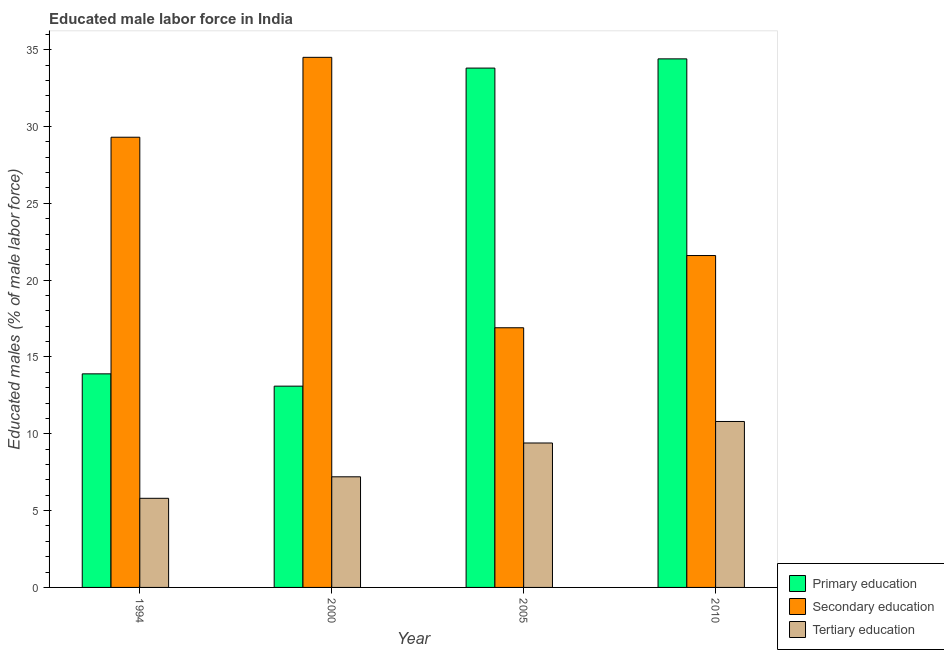How many different coloured bars are there?
Provide a short and direct response. 3. How many bars are there on the 1st tick from the left?
Provide a short and direct response. 3. How many bars are there on the 3rd tick from the right?
Give a very brief answer. 3. What is the label of the 4th group of bars from the left?
Your response must be concise. 2010. What is the percentage of male labor force who received primary education in 2010?
Your answer should be very brief. 34.4. Across all years, what is the maximum percentage of male labor force who received tertiary education?
Offer a very short reply. 10.8. Across all years, what is the minimum percentage of male labor force who received primary education?
Offer a terse response. 13.1. What is the total percentage of male labor force who received secondary education in the graph?
Your answer should be compact. 102.3. What is the difference between the percentage of male labor force who received tertiary education in 1994 and that in 2000?
Your response must be concise. -1.4. What is the difference between the percentage of male labor force who received primary education in 2000 and the percentage of male labor force who received tertiary education in 1994?
Your answer should be compact. -0.8. What is the average percentage of male labor force who received tertiary education per year?
Provide a succinct answer. 8.3. In the year 2005, what is the difference between the percentage of male labor force who received tertiary education and percentage of male labor force who received primary education?
Offer a terse response. 0. In how many years, is the percentage of male labor force who received tertiary education greater than 14 %?
Offer a terse response. 0. What is the ratio of the percentage of male labor force who received secondary education in 1994 to that in 2000?
Your answer should be compact. 0.85. Is the difference between the percentage of male labor force who received primary education in 2005 and 2010 greater than the difference between the percentage of male labor force who received tertiary education in 2005 and 2010?
Your answer should be compact. No. What is the difference between the highest and the second highest percentage of male labor force who received primary education?
Your answer should be very brief. 0.6. What is the difference between the highest and the lowest percentage of male labor force who received secondary education?
Offer a terse response. 17.6. In how many years, is the percentage of male labor force who received primary education greater than the average percentage of male labor force who received primary education taken over all years?
Your answer should be compact. 2. Is the sum of the percentage of male labor force who received tertiary education in 1994 and 2010 greater than the maximum percentage of male labor force who received primary education across all years?
Your answer should be very brief. Yes. What does the 2nd bar from the left in 2010 represents?
Make the answer very short. Secondary education. Is it the case that in every year, the sum of the percentage of male labor force who received primary education and percentage of male labor force who received secondary education is greater than the percentage of male labor force who received tertiary education?
Your response must be concise. Yes. How many bars are there?
Offer a terse response. 12. Are all the bars in the graph horizontal?
Give a very brief answer. No. How many years are there in the graph?
Your answer should be very brief. 4. Where does the legend appear in the graph?
Make the answer very short. Bottom right. How are the legend labels stacked?
Your answer should be compact. Vertical. What is the title of the graph?
Provide a succinct answer. Educated male labor force in India. Does "Ages 0-14" appear as one of the legend labels in the graph?
Your answer should be very brief. No. What is the label or title of the X-axis?
Your response must be concise. Year. What is the label or title of the Y-axis?
Keep it short and to the point. Educated males (% of male labor force). What is the Educated males (% of male labor force) in Primary education in 1994?
Your answer should be very brief. 13.9. What is the Educated males (% of male labor force) in Secondary education in 1994?
Your answer should be very brief. 29.3. What is the Educated males (% of male labor force) of Tertiary education in 1994?
Offer a very short reply. 5.8. What is the Educated males (% of male labor force) in Primary education in 2000?
Your answer should be compact. 13.1. What is the Educated males (% of male labor force) in Secondary education in 2000?
Make the answer very short. 34.5. What is the Educated males (% of male labor force) in Tertiary education in 2000?
Your answer should be very brief. 7.2. What is the Educated males (% of male labor force) in Primary education in 2005?
Keep it short and to the point. 33.8. What is the Educated males (% of male labor force) of Secondary education in 2005?
Your answer should be compact. 16.9. What is the Educated males (% of male labor force) in Tertiary education in 2005?
Offer a very short reply. 9.4. What is the Educated males (% of male labor force) in Primary education in 2010?
Ensure brevity in your answer.  34.4. What is the Educated males (% of male labor force) in Secondary education in 2010?
Keep it short and to the point. 21.6. What is the Educated males (% of male labor force) of Tertiary education in 2010?
Provide a short and direct response. 10.8. Across all years, what is the maximum Educated males (% of male labor force) in Primary education?
Give a very brief answer. 34.4. Across all years, what is the maximum Educated males (% of male labor force) of Secondary education?
Offer a terse response. 34.5. Across all years, what is the maximum Educated males (% of male labor force) in Tertiary education?
Ensure brevity in your answer.  10.8. Across all years, what is the minimum Educated males (% of male labor force) in Primary education?
Provide a short and direct response. 13.1. Across all years, what is the minimum Educated males (% of male labor force) in Secondary education?
Your answer should be compact. 16.9. Across all years, what is the minimum Educated males (% of male labor force) in Tertiary education?
Keep it short and to the point. 5.8. What is the total Educated males (% of male labor force) of Primary education in the graph?
Make the answer very short. 95.2. What is the total Educated males (% of male labor force) in Secondary education in the graph?
Provide a short and direct response. 102.3. What is the total Educated males (% of male labor force) of Tertiary education in the graph?
Your answer should be very brief. 33.2. What is the difference between the Educated males (% of male labor force) in Primary education in 1994 and that in 2000?
Your answer should be very brief. 0.8. What is the difference between the Educated males (% of male labor force) in Primary education in 1994 and that in 2005?
Make the answer very short. -19.9. What is the difference between the Educated males (% of male labor force) in Secondary education in 1994 and that in 2005?
Give a very brief answer. 12.4. What is the difference between the Educated males (% of male labor force) in Tertiary education in 1994 and that in 2005?
Make the answer very short. -3.6. What is the difference between the Educated males (% of male labor force) of Primary education in 1994 and that in 2010?
Keep it short and to the point. -20.5. What is the difference between the Educated males (% of male labor force) in Tertiary education in 1994 and that in 2010?
Your response must be concise. -5. What is the difference between the Educated males (% of male labor force) in Primary education in 2000 and that in 2005?
Provide a succinct answer. -20.7. What is the difference between the Educated males (% of male labor force) of Primary education in 2000 and that in 2010?
Offer a terse response. -21.3. What is the difference between the Educated males (% of male labor force) in Primary education in 2005 and that in 2010?
Give a very brief answer. -0.6. What is the difference between the Educated males (% of male labor force) of Primary education in 1994 and the Educated males (% of male labor force) of Secondary education in 2000?
Provide a short and direct response. -20.6. What is the difference between the Educated males (% of male labor force) in Primary education in 1994 and the Educated males (% of male labor force) in Tertiary education in 2000?
Keep it short and to the point. 6.7. What is the difference between the Educated males (% of male labor force) in Secondary education in 1994 and the Educated males (% of male labor force) in Tertiary education in 2000?
Ensure brevity in your answer.  22.1. What is the difference between the Educated males (% of male labor force) in Primary education in 1994 and the Educated males (% of male labor force) in Secondary education in 2005?
Offer a terse response. -3. What is the difference between the Educated males (% of male labor force) in Secondary education in 1994 and the Educated males (% of male labor force) in Tertiary education in 2005?
Your response must be concise. 19.9. What is the difference between the Educated males (% of male labor force) of Primary education in 1994 and the Educated males (% of male labor force) of Secondary education in 2010?
Keep it short and to the point. -7.7. What is the difference between the Educated males (% of male labor force) in Primary education in 2000 and the Educated males (% of male labor force) in Tertiary education in 2005?
Your answer should be very brief. 3.7. What is the difference between the Educated males (% of male labor force) in Secondary education in 2000 and the Educated males (% of male labor force) in Tertiary education in 2005?
Give a very brief answer. 25.1. What is the difference between the Educated males (% of male labor force) of Primary education in 2000 and the Educated males (% of male labor force) of Secondary education in 2010?
Offer a very short reply. -8.5. What is the difference between the Educated males (% of male labor force) of Secondary education in 2000 and the Educated males (% of male labor force) of Tertiary education in 2010?
Provide a short and direct response. 23.7. What is the difference between the Educated males (% of male labor force) in Primary education in 2005 and the Educated males (% of male labor force) in Secondary education in 2010?
Offer a terse response. 12.2. What is the difference between the Educated males (% of male labor force) of Secondary education in 2005 and the Educated males (% of male labor force) of Tertiary education in 2010?
Your response must be concise. 6.1. What is the average Educated males (% of male labor force) of Primary education per year?
Ensure brevity in your answer.  23.8. What is the average Educated males (% of male labor force) of Secondary education per year?
Your answer should be compact. 25.57. In the year 1994, what is the difference between the Educated males (% of male labor force) of Primary education and Educated males (% of male labor force) of Secondary education?
Provide a short and direct response. -15.4. In the year 1994, what is the difference between the Educated males (% of male labor force) of Secondary education and Educated males (% of male labor force) of Tertiary education?
Offer a very short reply. 23.5. In the year 2000, what is the difference between the Educated males (% of male labor force) in Primary education and Educated males (% of male labor force) in Secondary education?
Your answer should be compact. -21.4. In the year 2000, what is the difference between the Educated males (% of male labor force) in Secondary education and Educated males (% of male labor force) in Tertiary education?
Your answer should be compact. 27.3. In the year 2005, what is the difference between the Educated males (% of male labor force) in Primary education and Educated males (% of male labor force) in Tertiary education?
Provide a succinct answer. 24.4. In the year 2005, what is the difference between the Educated males (% of male labor force) of Secondary education and Educated males (% of male labor force) of Tertiary education?
Offer a very short reply. 7.5. In the year 2010, what is the difference between the Educated males (% of male labor force) in Primary education and Educated males (% of male labor force) in Tertiary education?
Your answer should be very brief. 23.6. What is the ratio of the Educated males (% of male labor force) in Primary education in 1994 to that in 2000?
Provide a succinct answer. 1.06. What is the ratio of the Educated males (% of male labor force) in Secondary education in 1994 to that in 2000?
Offer a very short reply. 0.85. What is the ratio of the Educated males (% of male labor force) in Tertiary education in 1994 to that in 2000?
Your answer should be very brief. 0.81. What is the ratio of the Educated males (% of male labor force) in Primary education in 1994 to that in 2005?
Your answer should be very brief. 0.41. What is the ratio of the Educated males (% of male labor force) in Secondary education in 1994 to that in 2005?
Give a very brief answer. 1.73. What is the ratio of the Educated males (% of male labor force) of Tertiary education in 1994 to that in 2005?
Give a very brief answer. 0.62. What is the ratio of the Educated males (% of male labor force) of Primary education in 1994 to that in 2010?
Give a very brief answer. 0.4. What is the ratio of the Educated males (% of male labor force) in Secondary education in 1994 to that in 2010?
Make the answer very short. 1.36. What is the ratio of the Educated males (% of male labor force) in Tertiary education in 1994 to that in 2010?
Your answer should be very brief. 0.54. What is the ratio of the Educated males (% of male labor force) in Primary education in 2000 to that in 2005?
Provide a succinct answer. 0.39. What is the ratio of the Educated males (% of male labor force) in Secondary education in 2000 to that in 2005?
Provide a succinct answer. 2.04. What is the ratio of the Educated males (% of male labor force) of Tertiary education in 2000 to that in 2005?
Offer a very short reply. 0.77. What is the ratio of the Educated males (% of male labor force) in Primary education in 2000 to that in 2010?
Provide a succinct answer. 0.38. What is the ratio of the Educated males (% of male labor force) of Secondary education in 2000 to that in 2010?
Provide a succinct answer. 1.6. What is the ratio of the Educated males (% of male labor force) in Primary education in 2005 to that in 2010?
Ensure brevity in your answer.  0.98. What is the ratio of the Educated males (% of male labor force) in Secondary education in 2005 to that in 2010?
Give a very brief answer. 0.78. What is the ratio of the Educated males (% of male labor force) of Tertiary education in 2005 to that in 2010?
Offer a very short reply. 0.87. What is the difference between the highest and the lowest Educated males (% of male labor force) in Primary education?
Provide a short and direct response. 21.3. What is the difference between the highest and the lowest Educated males (% of male labor force) of Secondary education?
Make the answer very short. 17.6. 